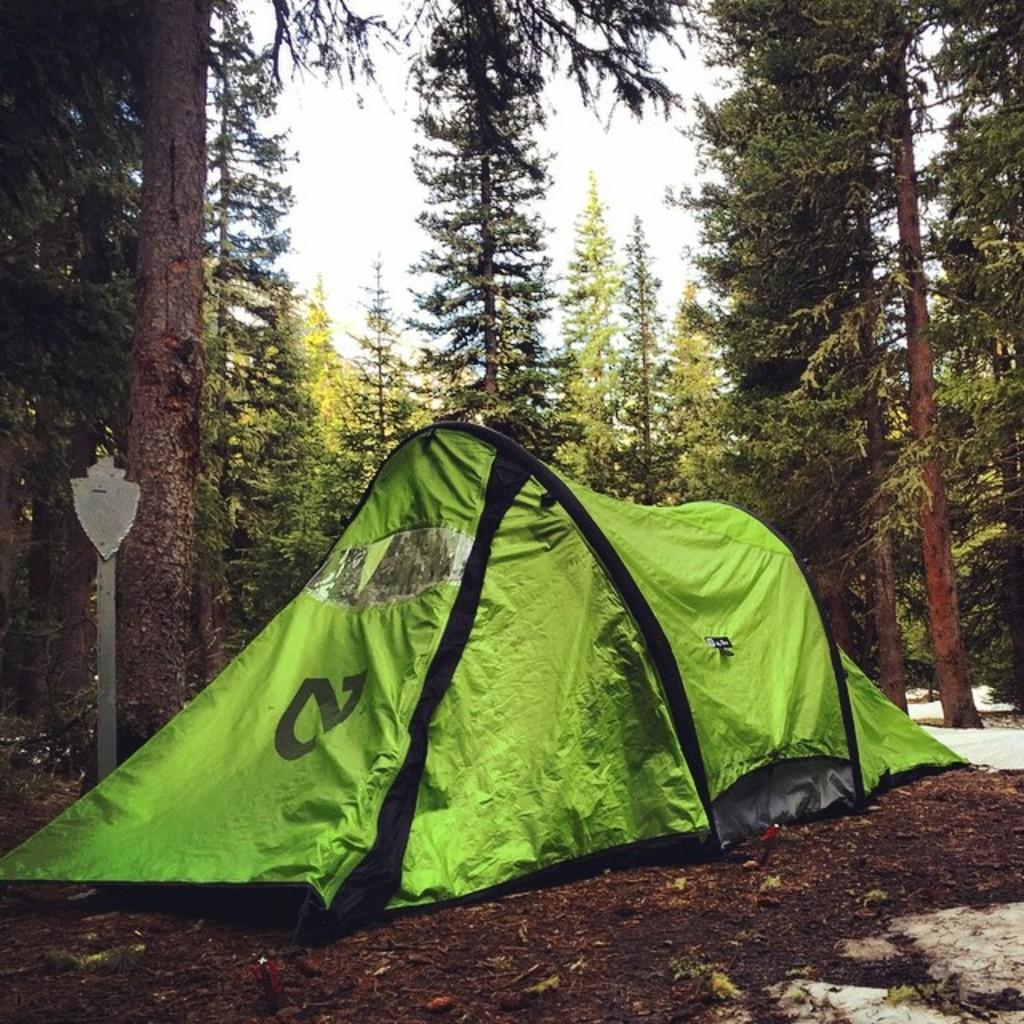What type of shelter is visible in the image? There is a hiking tent in the image. Where is the tent located? The tent is on the ground. What can be seen in the background of the image? There are many tall trees around the tent. What type of window can be seen in the image? There is no window present in the image; it features a hiking tent on the ground surrounded by tall trees. 